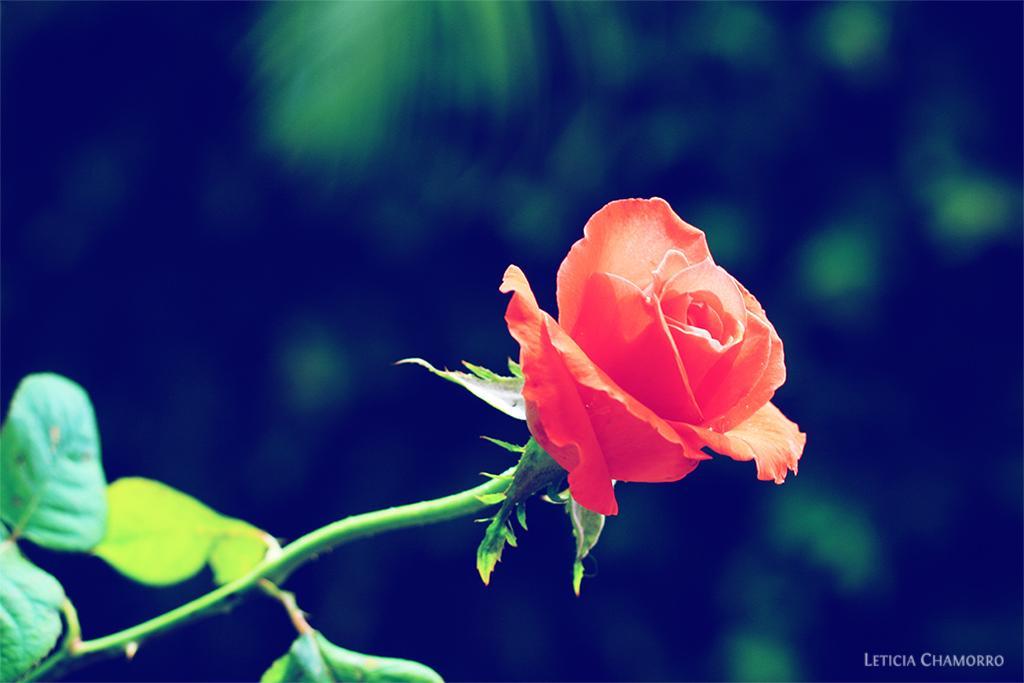How would you summarize this image in a sentence or two? In this image I can see a rose flower. The background is blurry. 